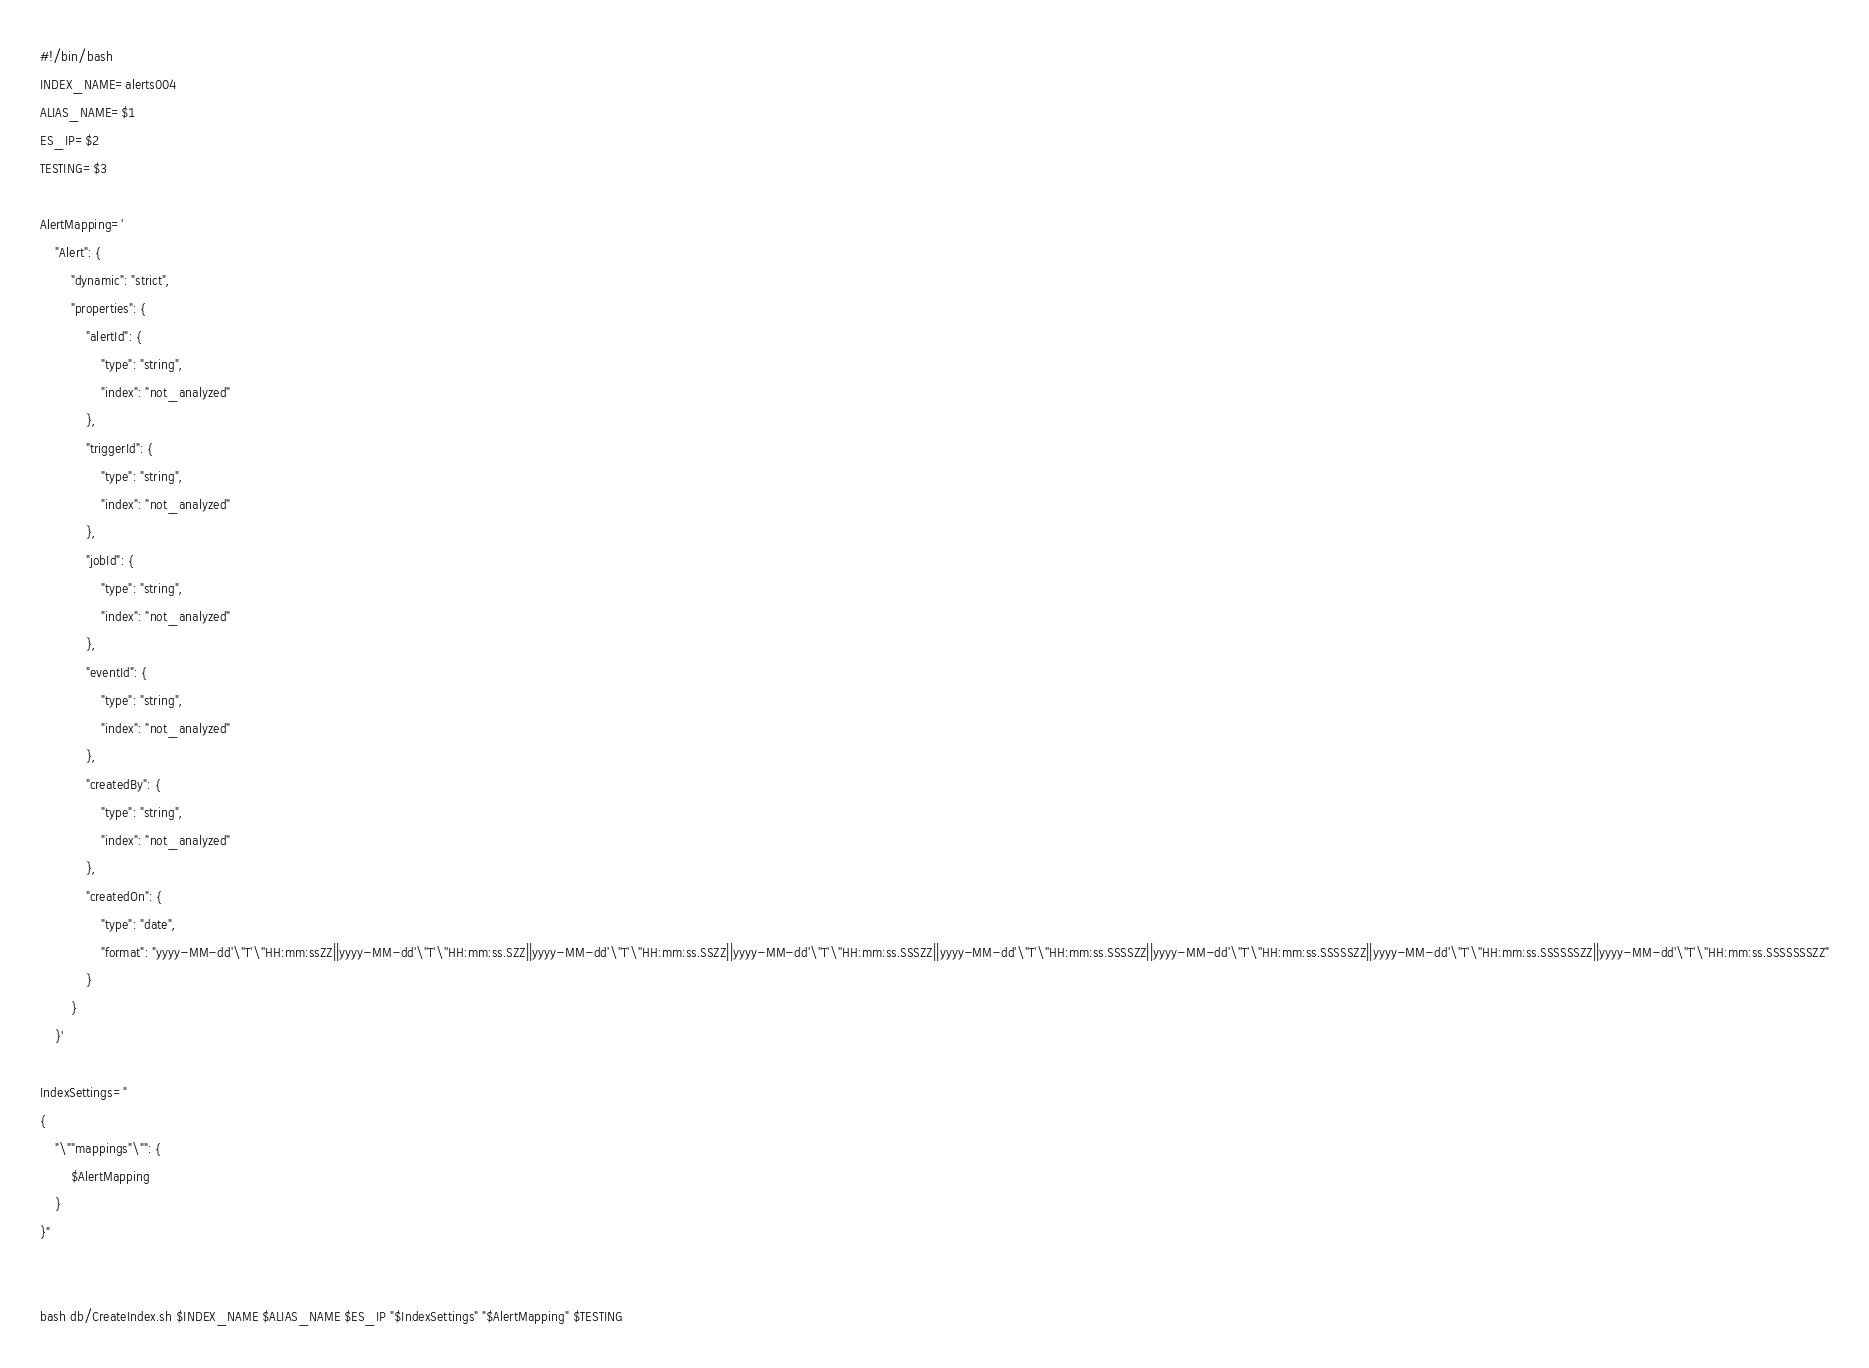Convert code to text. <code><loc_0><loc_0><loc_500><loc_500><_Bash_>#!/bin/bash
INDEX_NAME=alerts004
ALIAS_NAME=$1
ES_IP=$2
TESTING=$3

AlertMapping='
	"Alert": {
		"dynamic": "strict",
		"properties": {
			"alertId": {
				"type": "string",
				"index": "not_analyzed"
			},
			"triggerId": {
				"type": "string",
				"index": "not_analyzed"
			},
			"jobId": {
				"type": "string",
				"index": "not_analyzed"
			},
			"eventId": {
				"type": "string",
				"index": "not_analyzed"
			},
			"createdBy": {
				"type": "string",
				"index": "not_analyzed"
			},
			"createdOn": {
				"type": "date",
				"format": "yyyy-MM-dd'\''T'\''HH:mm:ssZZ||yyyy-MM-dd'\''T'\''HH:mm:ss.SZZ||yyyy-MM-dd'\''T'\''HH:mm:ss.SSZZ||yyyy-MM-dd'\''T'\''HH:mm:ss.SSSZZ||yyyy-MM-dd'\''T'\''HH:mm:ss.SSSSZZ||yyyy-MM-dd'\''T'\''HH:mm:ss.SSSSSZZ||yyyy-MM-dd'\''T'\''HH:mm:ss.SSSSSSZZ||yyyy-MM-dd'\''T'\''HH:mm:ss.SSSSSSSZZ"
			}
		}
	}'

IndexSettings="
{
	"\""mappings"\"": {
		$AlertMapping
	}
}"


bash db/CreateIndex.sh $INDEX_NAME $ALIAS_NAME $ES_IP "$IndexSettings" "$AlertMapping" $TESTING</code> 